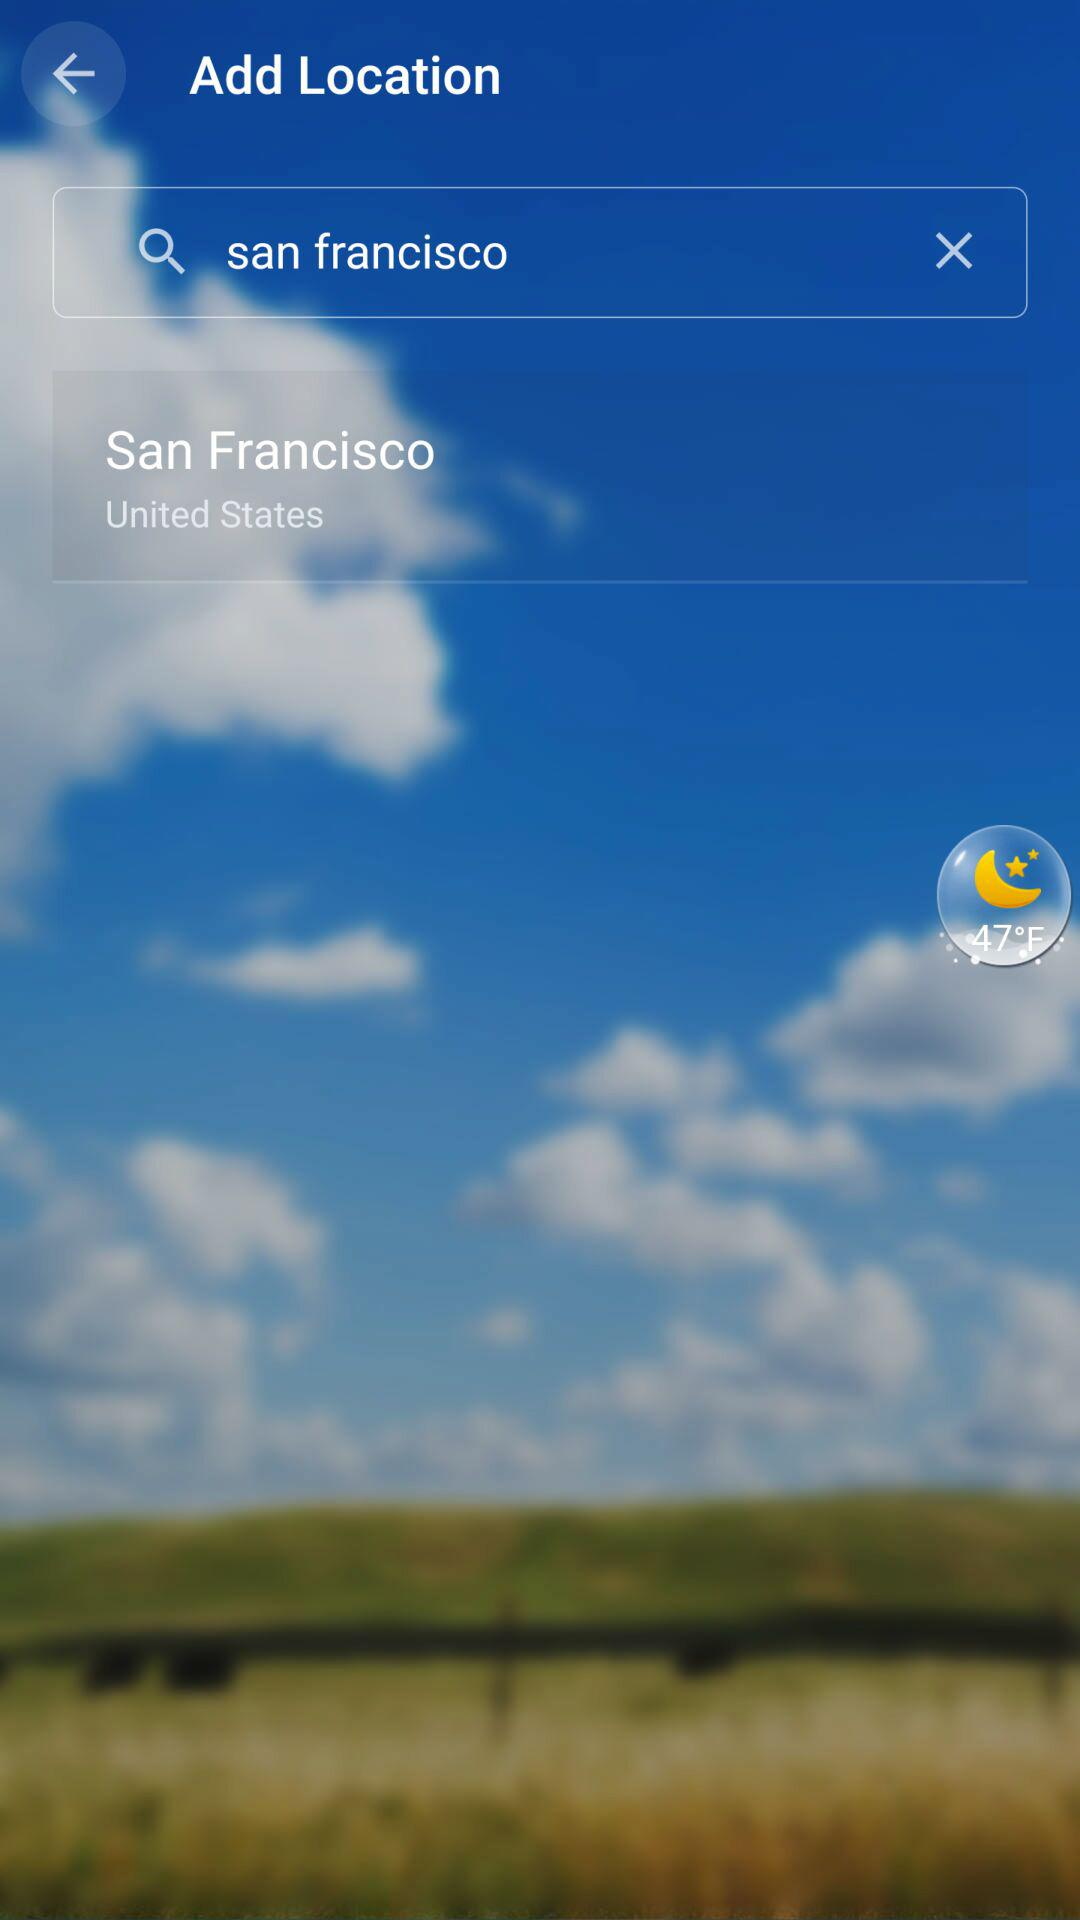What new locations have been searched for? The new location that has been searched is San Francisco, United States. 